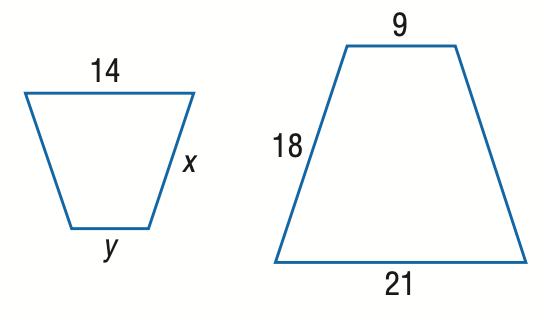Question: Find x.
Choices:
A. 9
B. 12
C. 15
D. 16
Answer with the letter. Answer: B Question: Find y.
Choices:
A. 6
B. 7
C. 9
D. 12
Answer with the letter. Answer: A 